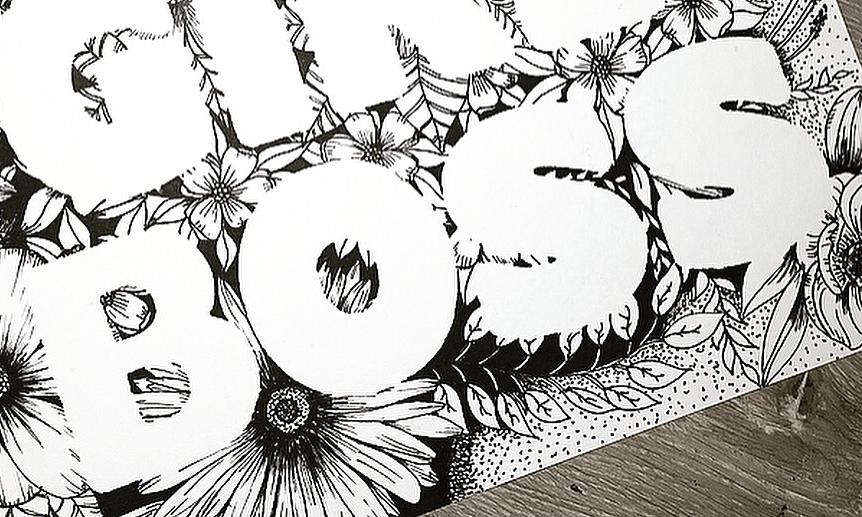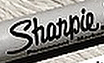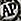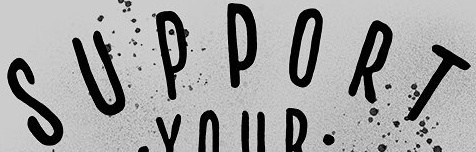Read the text content from these images in order, separated by a semicolon. BOSS; Shanpie; AP; SUPPORT 